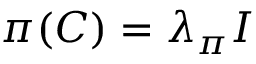<formula> <loc_0><loc_0><loc_500><loc_500>\pi ( C ) = \lambda _ { \pi } I</formula> 